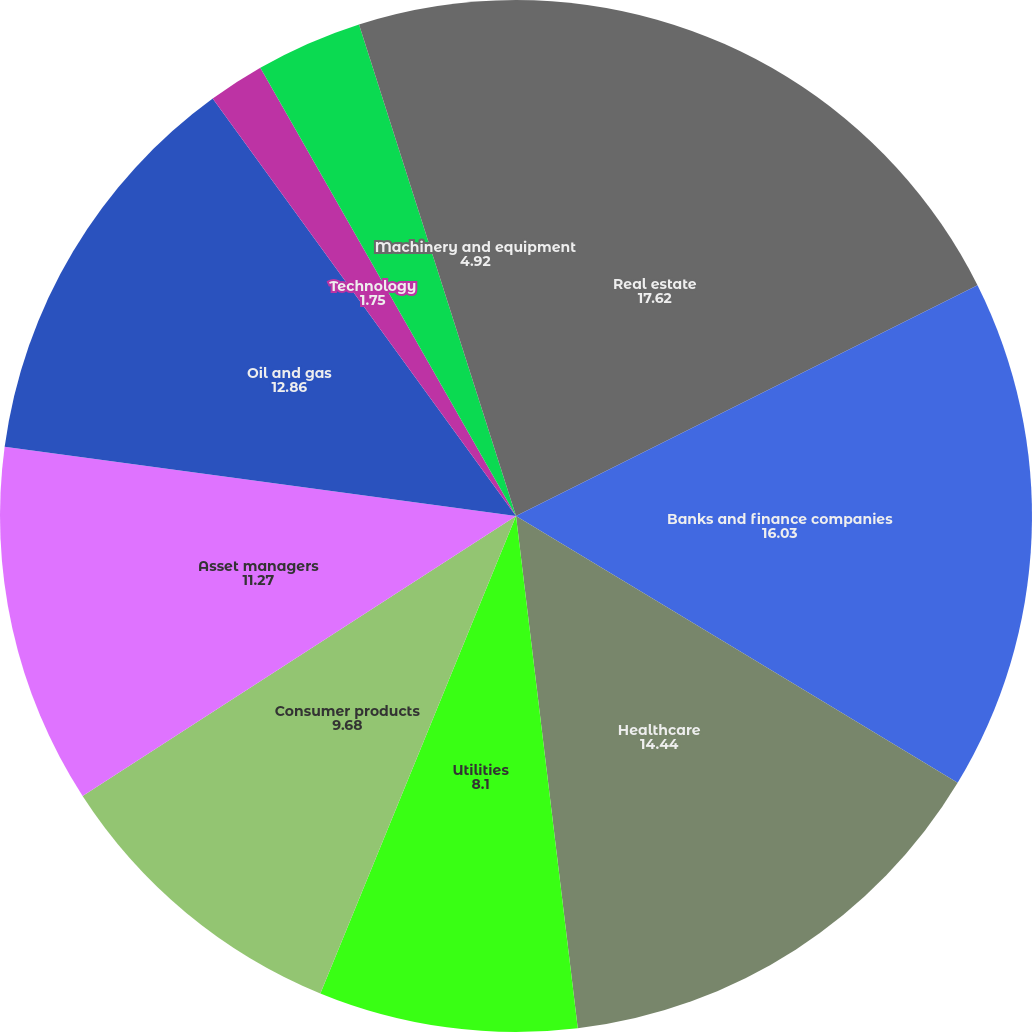Convert chart to OTSL. <chart><loc_0><loc_0><loc_500><loc_500><pie_chart><fcel>Real estate<fcel>Banks and finance companies<fcel>Healthcare<fcel>Utilities<fcel>Consumer products<fcel>Asset managers<fcel>Oil and gas<fcel>Technology<fcel>Insurance<fcel>Machinery and equipment<nl><fcel>17.62%<fcel>16.03%<fcel>14.44%<fcel>8.1%<fcel>9.68%<fcel>11.27%<fcel>12.86%<fcel>1.75%<fcel>3.33%<fcel>4.92%<nl></chart> 